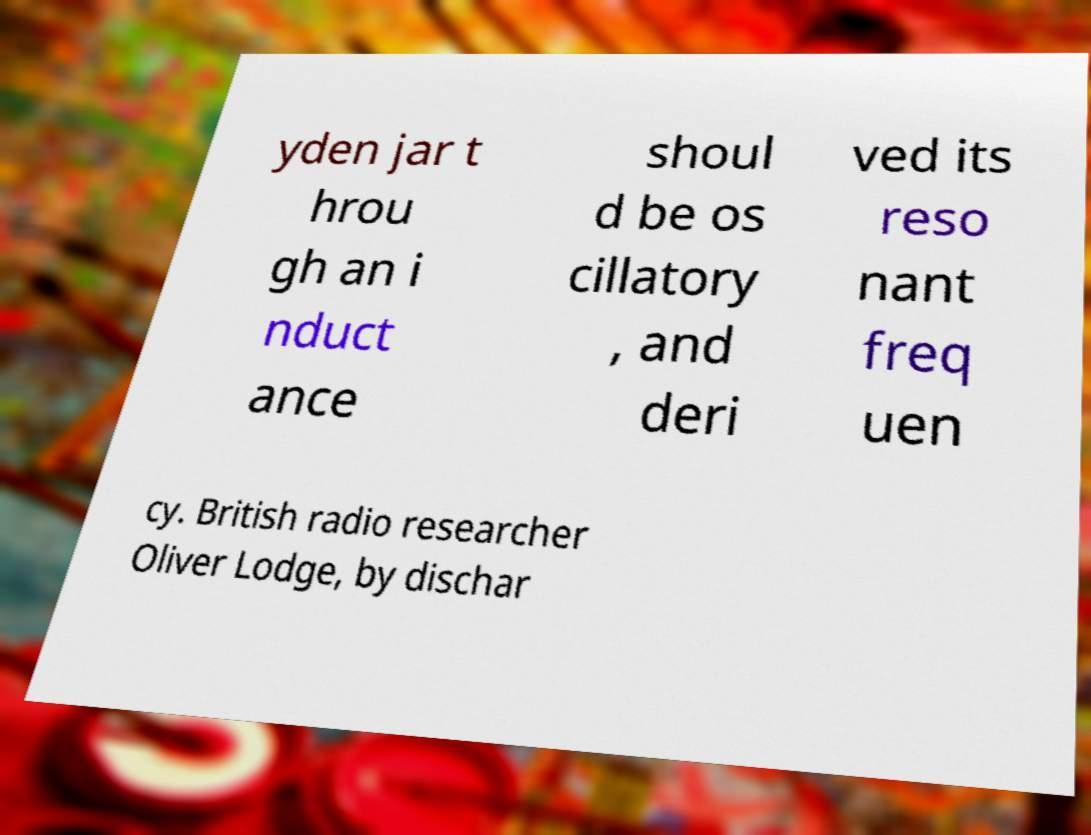Please read and relay the text visible in this image. What does it say? yden jar t hrou gh an i nduct ance shoul d be os cillatory , and deri ved its reso nant freq uen cy. British radio researcher Oliver Lodge, by dischar 